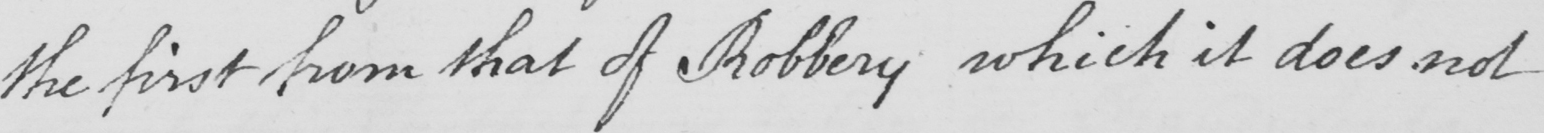Transcribe the text shown in this historical manuscript line. the first from that of Robbery which it does not 